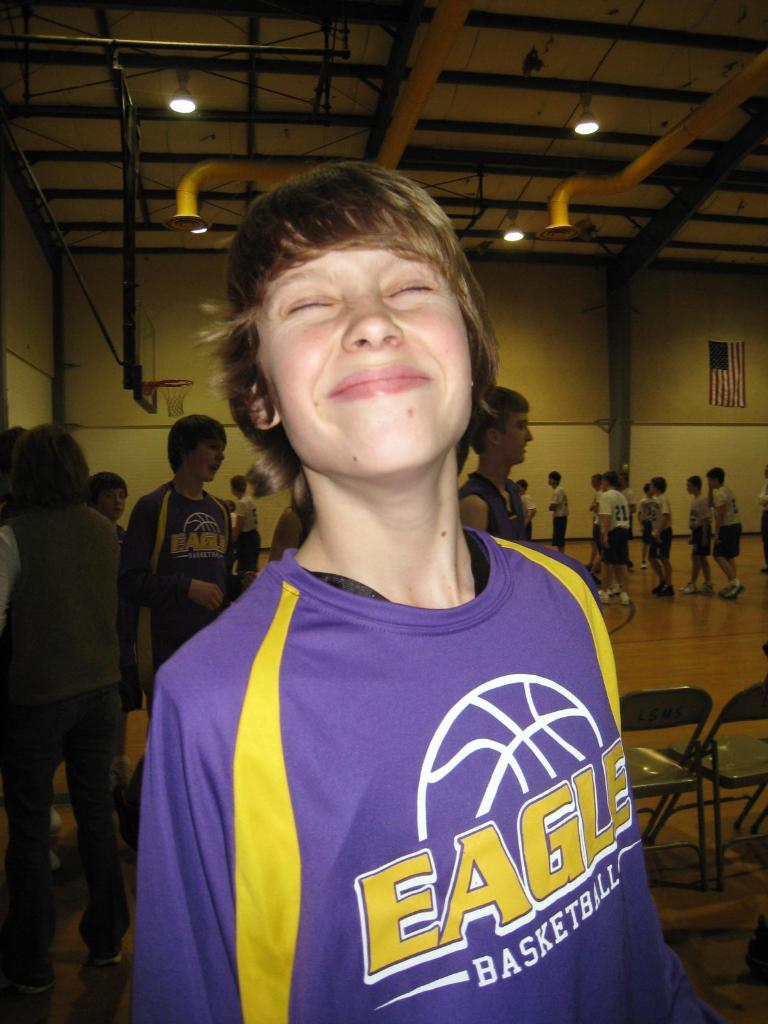<image>
Share a concise interpretation of the image provided. a boy wearing a uniform shirt that says 'eagles basketball' on it 